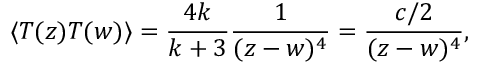<formula> <loc_0><loc_0><loc_500><loc_500>\langle T ( z ) T ( w ) \rangle = \frac { 4 k } { k + 3 } \frac { 1 } { ( z - w ) ^ { 4 } } = \frac { c / 2 } { ( z - w ) ^ { 4 } } ,</formula> 